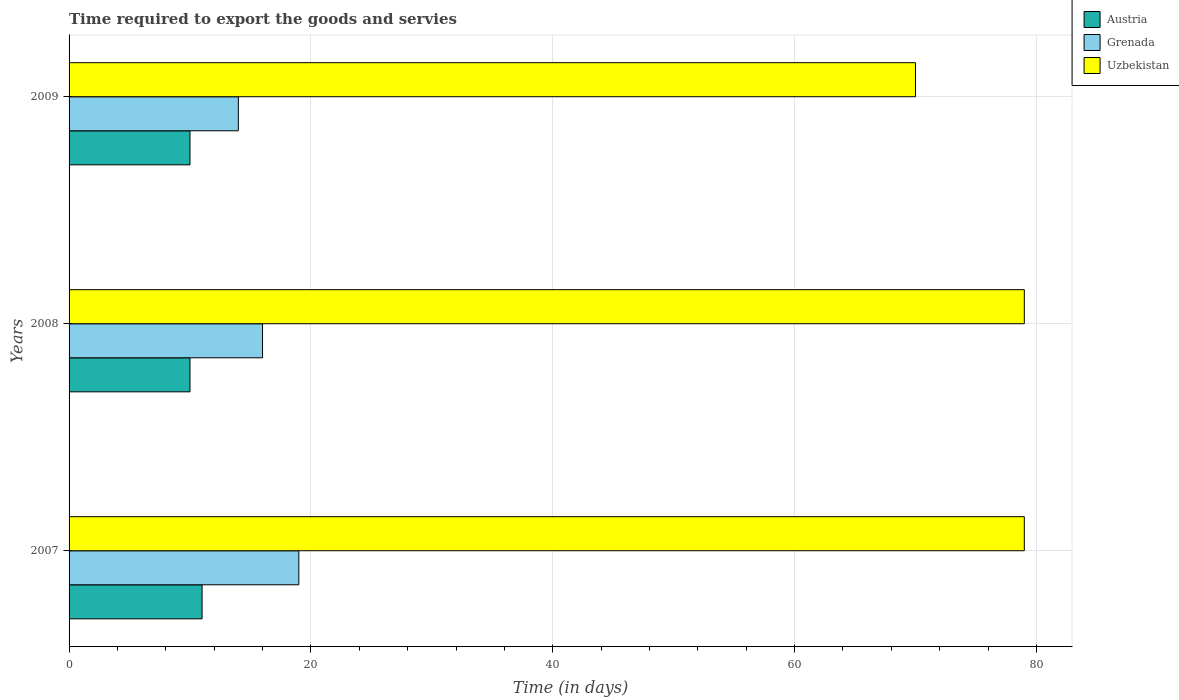How many groups of bars are there?
Provide a succinct answer. 3. Are the number of bars per tick equal to the number of legend labels?
Provide a short and direct response. Yes. How many bars are there on the 2nd tick from the top?
Your answer should be compact. 3. What is the number of days required to export the goods and services in Uzbekistan in 2009?
Offer a terse response. 70. Across all years, what is the maximum number of days required to export the goods and services in Uzbekistan?
Give a very brief answer. 79. Across all years, what is the minimum number of days required to export the goods and services in Uzbekistan?
Offer a terse response. 70. What is the total number of days required to export the goods and services in Grenada in the graph?
Give a very brief answer. 49. What is the difference between the number of days required to export the goods and services in Grenada in 2007 and that in 2009?
Your response must be concise. 5. What is the difference between the number of days required to export the goods and services in Grenada in 2009 and the number of days required to export the goods and services in Austria in 2008?
Offer a very short reply. 4. What is the average number of days required to export the goods and services in Grenada per year?
Your response must be concise. 16.33. In the year 2009, what is the difference between the number of days required to export the goods and services in Grenada and number of days required to export the goods and services in Austria?
Your response must be concise. 4. In how many years, is the number of days required to export the goods and services in Uzbekistan greater than 52 days?
Offer a very short reply. 3. What is the ratio of the number of days required to export the goods and services in Grenada in 2007 to that in 2009?
Offer a terse response. 1.36. Is the number of days required to export the goods and services in Grenada in 2007 less than that in 2009?
Provide a succinct answer. No. What is the difference between the highest and the second highest number of days required to export the goods and services in Uzbekistan?
Your response must be concise. 0. What is the difference between the highest and the lowest number of days required to export the goods and services in Uzbekistan?
Provide a short and direct response. 9. What does the 1st bar from the top in 2008 represents?
Give a very brief answer. Uzbekistan. What does the 2nd bar from the bottom in 2007 represents?
Make the answer very short. Grenada. Is it the case that in every year, the sum of the number of days required to export the goods and services in Grenada and number of days required to export the goods and services in Austria is greater than the number of days required to export the goods and services in Uzbekistan?
Provide a short and direct response. No. How many bars are there?
Your answer should be compact. 9. Are the values on the major ticks of X-axis written in scientific E-notation?
Offer a very short reply. No. Does the graph contain any zero values?
Provide a succinct answer. No. How are the legend labels stacked?
Keep it short and to the point. Vertical. What is the title of the graph?
Keep it short and to the point. Time required to export the goods and servies. Does "China" appear as one of the legend labels in the graph?
Offer a very short reply. No. What is the label or title of the X-axis?
Your answer should be compact. Time (in days). What is the label or title of the Y-axis?
Your answer should be very brief. Years. What is the Time (in days) of Grenada in 2007?
Make the answer very short. 19. What is the Time (in days) of Uzbekistan in 2007?
Keep it short and to the point. 79. What is the Time (in days) of Austria in 2008?
Provide a short and direct response. 10. What is the Time (in days) of Grenada in 2008?
Your response must be concise. 16. What is the Time (in days) in Uzbekistan in 2008?
Your response must be concise. 79. What is the Time (in days) in Austria in 2009?
Provide a succinct answer. 10. What is the Time (in days) of Uzbekistan in 2009?
Provide a succinct answer. 70. Across all years, what is the maximum Time (in days) of Uzbekistan?
Your response must be concise. 79. Across all years, what is the minimum Time (in days) of Uzbekistan?
Your answer should be very brief. 70. What is the total Time (in days) of Austria in the graph?
Make the answer very short. 31. What is the total Time (in days) of Uzbekistan in the graph?
Your answer should be compact. 228. What is the difference between the Time (in days) in Austria in 2007 and that in 2009?
Your answer should be very brief. 1. What is the difference between the Time (in days) in Grenada in 2007 and that in 2009?
Ensure brevity in your answer.  5. What is the difference between the Time (in days) in Austria in 2008 and that in 2009?
Your response must be concise. 0. What is the difference between the Time (in days) of Austria in 2007 and the Time (in days) of Uzbekistan in 2008?
Your response must be concise. -68. What is the difference between the Time (in days) of Grenada in 2007 and the Time (in days) of Uzbekistan in 2008?
Ensure brevity in your answer.  -60. What is the difference between the Time (in days) in Austria in 2007 and the Time (in days) in Grenada in 2009?
Offer a very short reply. -3. What is the difference between the Time (in days) in Austria in 2007 and the Time (in days) in Uzbekistan in 2009?
Keep it short and to the point. -59. What is the difference between the Time (in days) in Grenada in 2007 and the Time (in days) in Uzbekistan in 2009?
Provide a short and direct response. -51. What is the difference between the Time (in days) in Austria in 2008 and the Time (in days) in Uzbekistan in 2009?
Give a very brief answer. -60. What is the difference between the Time (in days) in Grenada in 2008 and the Time (in days) in Uzbekistan in 2009?
Provide a succinct answer. -54. What is the average Time (in days) of Austria per year?
Offer a terse response. 10.33. What is the average Time (in days) in Grenada per year?
Provide a succinct answer. 16.33. What is the average Time (in days) in Uzbekistan per year?
Ensure brevity in your answer.  76. In the year 2007, what is the difference between the Time (in days) of Austria and Time (in days) of Grenada?
Your response must be concise. -8. In the year 2007, what is the difference between the Time (in days) of Austria and Time (in days) of Uzbekistan?
Provide a succinct answer. -68. In the year 2007, what is the difference between the Time (in days) of Grenada and Time (in days) of Uzbekistan?
Provide a short and direct response. -60. In the year 2008, what is the difference between the Time (in days) in Austria and Time (in days) in Grenada?
Your answer should be compact. -6. In the year 2008, what is the difference between the Time (in days) in Austria and Time (in days) in Uzbekistan?
Your answer should be very brief. -69. In the year 2008, what is the difference between the Time (in days) of Grenada and Time (in days) of Uzbekistan?
Provide a succinct answer. -63. In the year 2009, what is the difference between the Time (in days) of Austria and Time (in days) of Uzbekistan?
Your answer should be compact. -60. In the year 2009, what is the difference between the Time (in days) in Grenada and Time (in days) in Uzbekistan?
Give a very brief answer. -56. What is the ratio of the Time (in days) of Austria in 2007 to that in 2008?
Keep it short and to the point. 1.1. What is the ratio of the Time (in days) of Grenada in 2007 to that in 2008?
Your answer should be very brief. 1.19. What is the ratio of the Time (in days) of Grenada in 2007 to that in 2009?
Your answer should be compact. 1.36. What is the ratio of the Time (in days) in Uzbekistan in 2007 to that in 2009?
Provide a short and direct response. 1.13. What is the ratio of the Time (in days) of Austria in 2008 to that in 2009?
Provide a succinct answer. 1. What is the ratio of the Time (in days) of Grenada in 2008 to that in 2009?
Provide a succinct answer. 1.14. What is the ratio of the Time (in days) of Uzbekistan in 2008 to that in 2009?
Your answer should be compact. 1.13. What is the difference between the highest and the second highest Time (in days) in Uzbekistan?
Your answer should be compact. 0. 